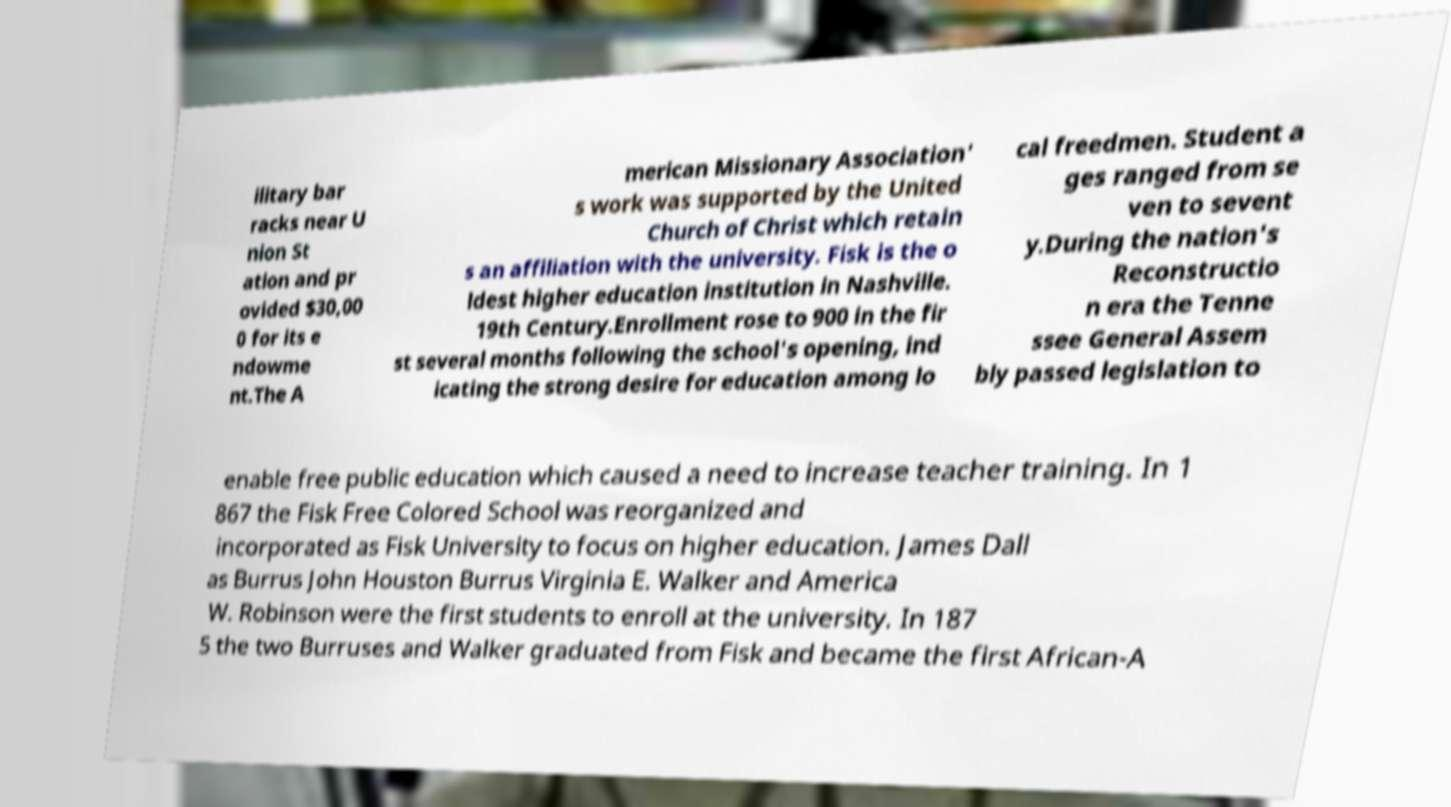Please identify and transcribe the text found in this image. ilitary bar racks near U nion St ation and pr ovided $30,00 0 for its e ndowme nt.The A merican Missionary Association' s work was supported by the United Church of Christ which retain s an affiliation with the university. Fisk is the o ldest higher education institution in Nashville. 19th Century.Enrollment rose to 900 in the fir st several months following the school's opening, ind icating the strong desire for education among lo cal freedmen. Student a ges ranged from se ven to sevent y.During the nation's Reconstructio n era the Tenne ssee General Assem bly passed legislation to enable free public education which caused a need to increase teacher training. In 1 867 the Fisk Free Colored School was reorganized and incorporated as Fisk University to focus on higher education. James Dall as Burrus John Houston Burrus Virginia E. Walker and America W. Robinson were the first students to enroll at the university. In 187 5 the two Burruses and Walker graduated from Fisk and became the first African-A 